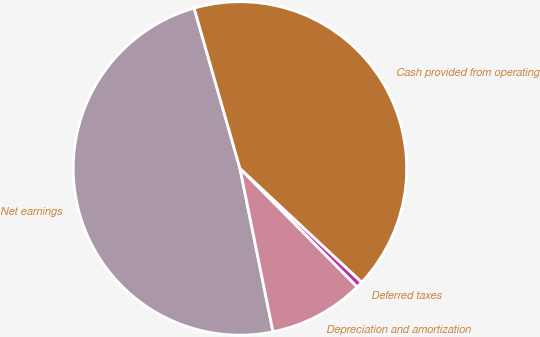Convert chart to OTSL. <chart><loc_0><loc_0><loc_500><loc_500><pie_chart><fcel>Net earnings<fcel>Depreciation and amortization<fcel>Deferred taxes<fcel>Cash provided from operating<nl><fcel>48.75%<fcel>9.24%<fcel>0.62%<fcel>41.4%<nl></chart> 